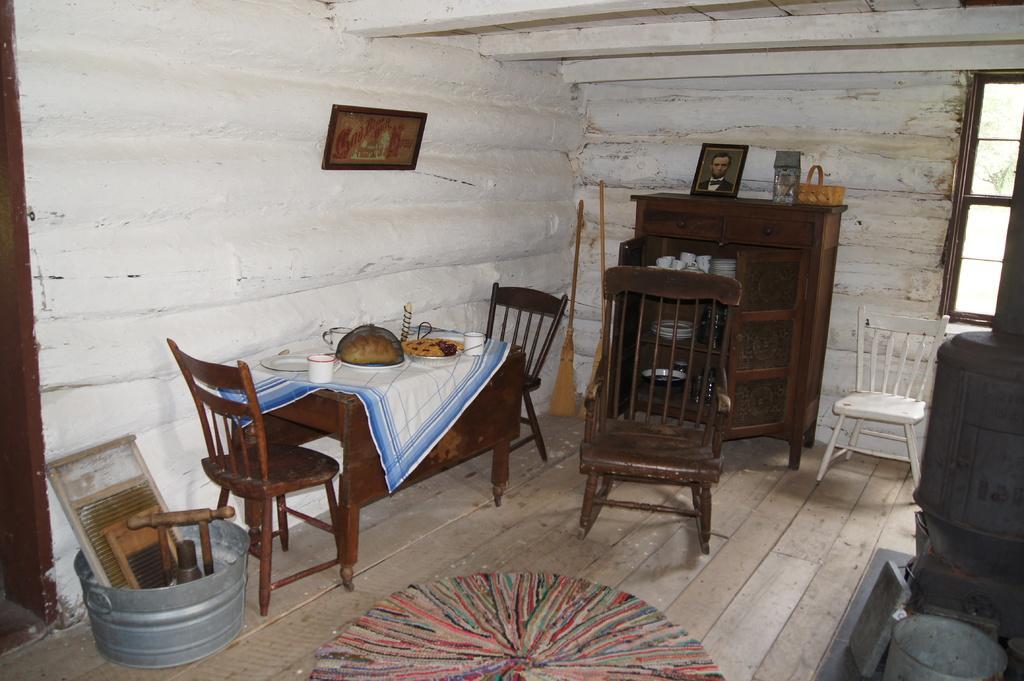Please provide a concise description of this image. In this picture, we can see the inside view of the room, and we can see the ground with some objects like table, chairs, desks, mat and we can see some container and some objects in it, we can see some objects on the table, broomstick, and we can see the wall with windows, photo frame, and we can see some object on the left side of the picture. 